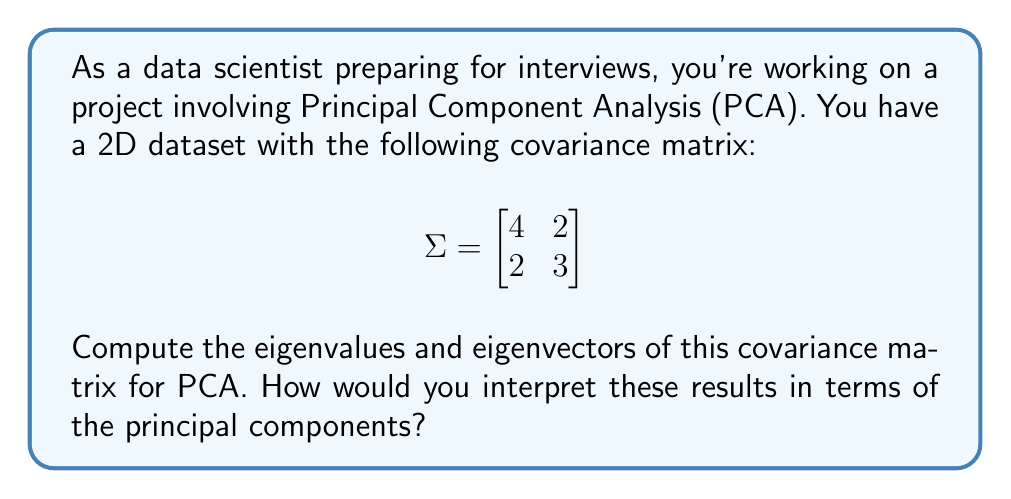Help me with this question. To find the eigenvalues and eigenvectors of the covariance matrix, we follow these steps:

1) First, we need to solve the characteristic equation:
   $$det(\Sigma - \lambda I) = 0$$

2) Expanding this:
   $$\begin{vmatrix}
   4-\lambda & 2 \\
   2 & 3-\lambda
   \end{vmatrix} = 0$$

3) This gives us:
   $$(4-\lambda)(3-\lambda) - 4 = 0$$
   $$\lambda^2 - 7\lambda + 8 = 0$$

4) Solving this quadratic equation:
   $$\lambda = \frac{7 \pm \sqrt{49 - 32}}{2} = \frac{7 \pm \sqrt{17}}{2}$$

5) Therefore, the eigenvalues are:
   $$\lambda_1 = \frac{7 + \sqrt{17}}{2} \approx 5.56$$
   $$\lambda_2 = \frac{7 - \sqrt{17}}{2} \approx 1.44$$

6) For each eigenvalue, we solve $(\Sigma - \lambda I)v = 0$ to find the corresponding eigenvector.

7) For $\lambda_1$:
   $$\begin{bmatrix}
   4-5.56 & 2 \\
   2 & 3-5.56
   \end{bmatrix}\begin{bmatrix}
   v_1 \\
   v_2
   \end{bmatrix} = \begin{bmatrix}
   0 \\
   0
   \end{bmatrix}$$

   This gives us: $v_2 \approx 0.851v_1$. Normalizing, we get:
   $$v_1 \approx [0.761, 0.649]^T$$

8) Similarly for $\lambda_2$, we get:
   $$v_2 \approx [-0.649, 0.761]^T$$

Interpretation: The first principal component (corresponding to $\lambda_1$) explains about 79.4% of the variance, while the second explains about 20.6%. The eigenvectors give the directions of these principal components in the original feature space.
Answer: Eigenvalues: $\lambda_1 \approx 5.56$, $\lambda_2 \approx 1.44$
Eigenvectors: $v_1 \approx [0.761, 0.649]^T$, $v_2 \approx [-0.649, 0.761]^T$ 